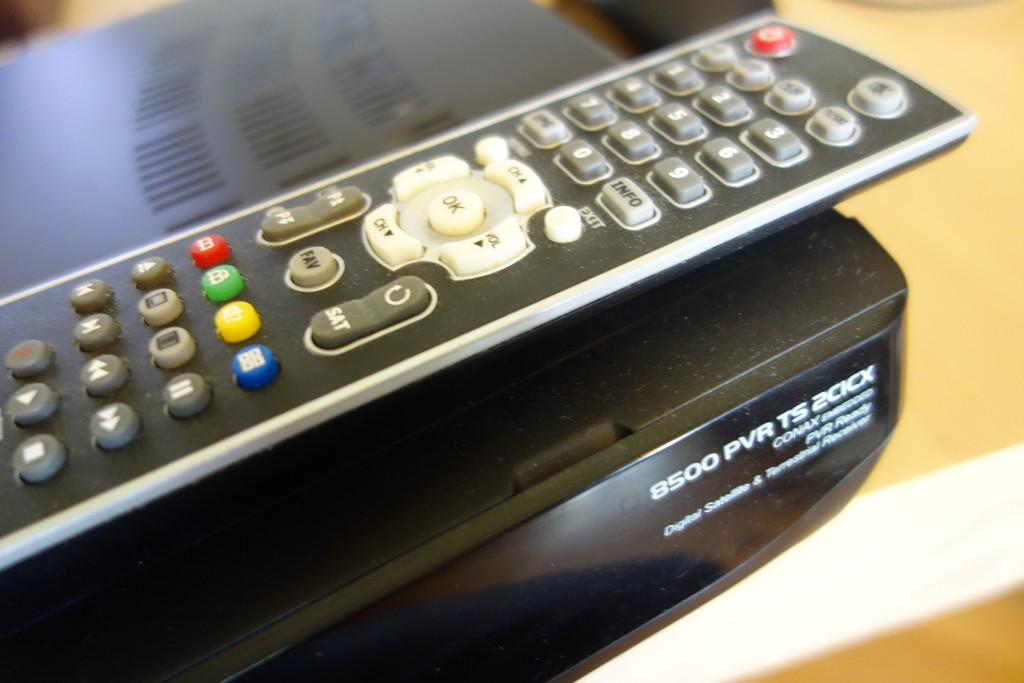<image>
Summarize the visual content of the image. remote control for the tv and pvr on the bottom 